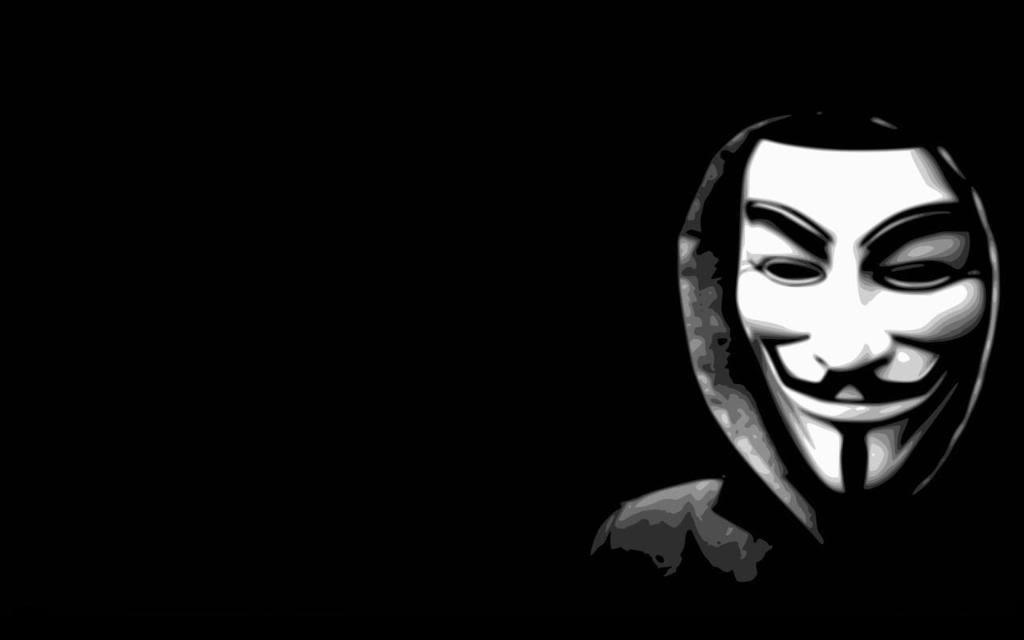What type of picture is the image? The image is an animated picture. Who is present in the image? There is a man in the image. What is the man wearing on his face? The man is wearing a mask. What can be observed about the background of the image? The background of the image is completely dark. What type of mint is growing in the image? There is no mint present in the image. What type of farming equipment can be seen in the image? There is no farming equipment or farmer present in the image. 